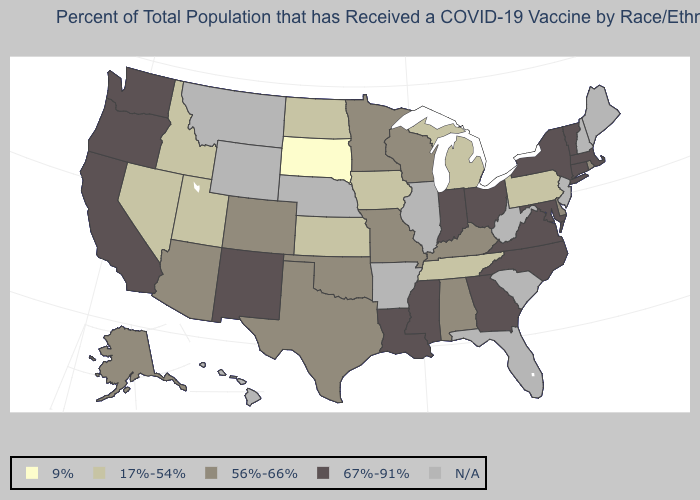Among the states that border Montana , does South Dakota have the lowest value?
Give a very brief answer. Yes. Which states have the highest value in the USA?
Answer briefly. California, Connecticut, Georgia, Indiana, Louisiana, Maryland, Massachusetts, Mississippi, New Mexico, New York, North Carolina, Ohio, Oregon, Vermont, Virginia, Washington. What is the value of Utah?
Give a very brief answer. 17%-54%. Among the states that border Virginia , which have the highest value?
Be succinct. Maryland, North Carolina. Does Kansas have the highest value in the MidWest?
Give a very brief answer. No. Name the states that have a value in the range 9%?
Short answer required. South Dakota. What is the value of Iowa?
Short answer required. 17%-54%. What is the highest value in states that border Nebraska?
Concise answer only. 56%-66%. What is the lowest value in the West?
Be succinct. 17%-54%. Is the legend a continuous bar?
Be succinct. No. Is the legend a continuous bar?
Quick response, please. No. Is the legend a continuous bar?
Write a very short answer. No. Is the legend a continuous bar?
Write a very short answer. No. What is the value of Maine?
Be succinct. N/A. 